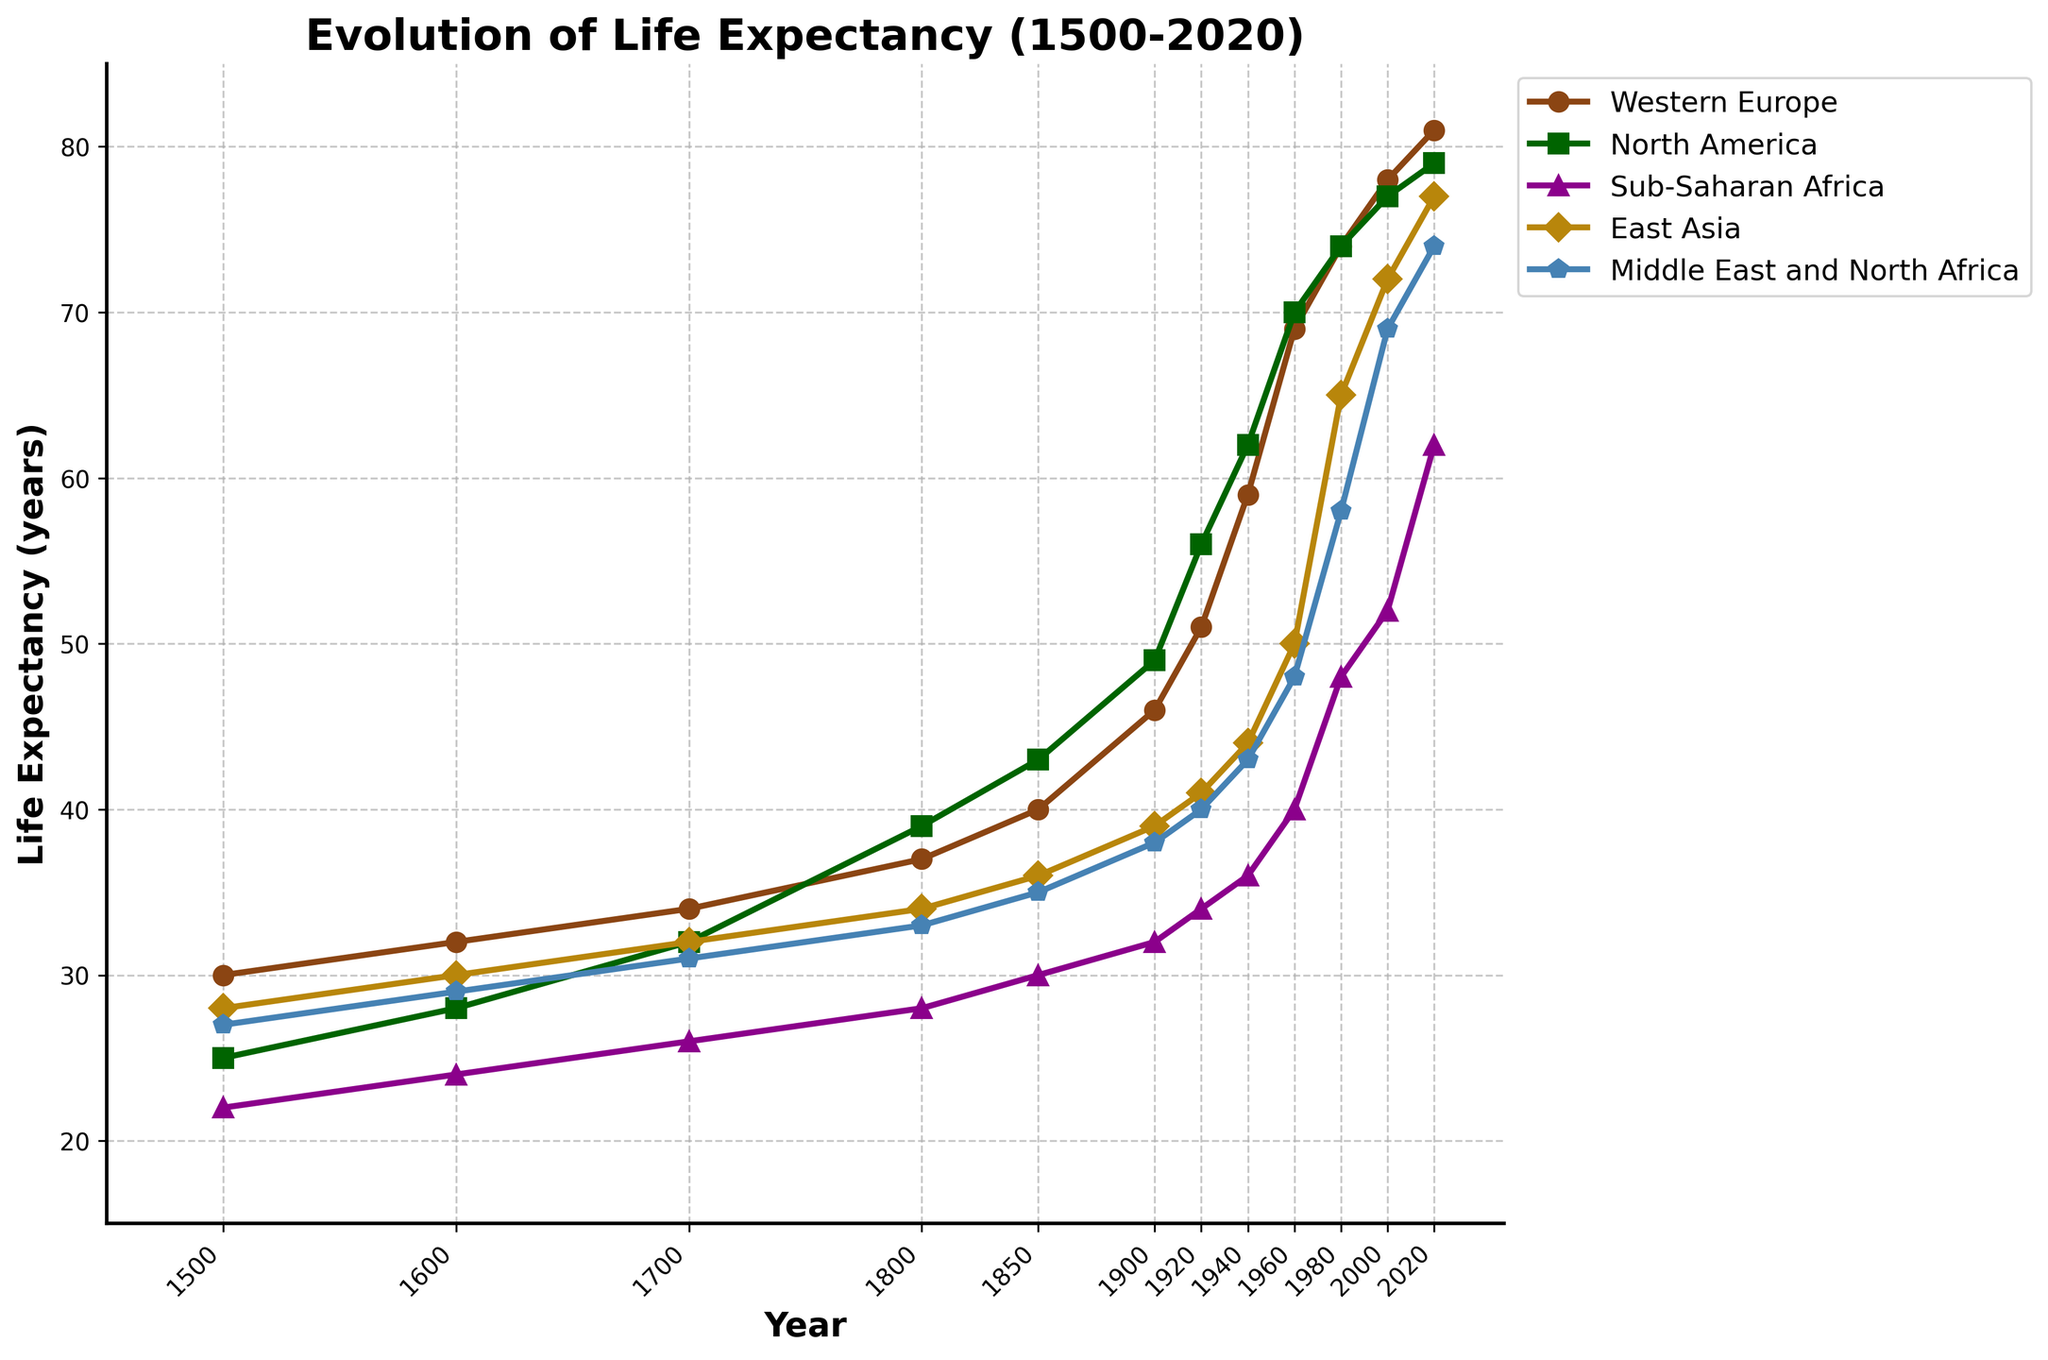What is the life expectancy in North America in 2020 compared to Sub-Saharan Africa in 2020? To answer this, locate the endpoints of the lines for North America and Sub-Saharan Africa in 2020. North America's endpoint is at 79 years while Sub-Saharan Africa's is at 62 years. Compare the two values: 79 - 62 = 17.
Answer: 17 years In which year did East Asia's life expectancy first surpass 50 years? Trace the line for East Asia and find when it first crossed the 50-year mark. Upon inspection, East Asia's life expectancy is 50 years in the year 1960.
Answer: 1960 Which region showed the most significant increase in life expectancy from 1960 to 2000? Calculate the differences in life expectancy for each region between 1960 and 2000. Western Europe went from 69 to 78 (9 years), North America from 70 to 77 (7 years), Sub-Saharan Africa from 40 to 52 (12 years), East Asia from 50 to 72 (22 years), and Middle East and North Africa from 48 to 69 (21 years). The largest increase was in East Asia.
Answer: East Asia Between 1800 and 1940, which region's life expectancy increased the least? Calculate the differences in life expectancy for each region between 1800 and 1940. Western Europe (37 to 59, increase of 22), North America (39 to 62, increase of 23), Sub-Saharan Africa (28 to 36, increase of 8), East Asia (34 to 44, increase of 10), and Middle East and North Africa (33 to 43, increase of 10). The least increase was in Sub-Saharan Africa.
Answer: Sub-Saharan Africa Compare the life expectancy trends of Western Europe and East Asia from 1500 to 2020. Examine the trajectory of the lines for Western Europe and East Asia. Western Europe shows a consistent, steady increase. East Asia displays a slower increase initially, then a sharp rise starting around the mid-20th century, finally nearing the life expectancy levels of Western Europe by 2020.
Answer: Western Europe consistently higher, East Asia rapidly catches up Which region had the highest life expectancy in 1700 and what was the value? Locate the point for 1700 on each line and identify the highest. North America has the highest life expectancy in 1700, with a value of 32 years.
Answer: North America, 32 years By how many years did life expectancy in the Middle East and North Africa increase from 1900 to 2020? Subtract the life expectancy in 1900 for the Middle East and North Africa from the life expectancy in 2020. 74 - 38 = 36 years.
Answer: 36 years When comparing the years 1800 and 1920, which region showed the most improvement in life expectancy and by how much? Calculate the increments for each region between 1800 and 1920: Western Europe (37 to 51, increase of 14), North America (39 to 56, increase of 17), Sub-Saharan Africa (28 to 34, increase of 6), East Asia (34 to 41, increase of 7), and Middle East and North Africa (33 to 40, increase of 7). North America shows the most improvement with an increment of 17 years.
Answer: North America, 17 years Looking at the evolution of life expectancy from 1500 to 2020, which region experienced the slowest initial growth but had a prominent rise in the modern era? Identify the region with the least growth from 1500 to around 1940 but a sharp increase thereafter. East Asia’s initial growth is slow until the mid-20th century, followed by a significant increase.
Answer: East Asia 